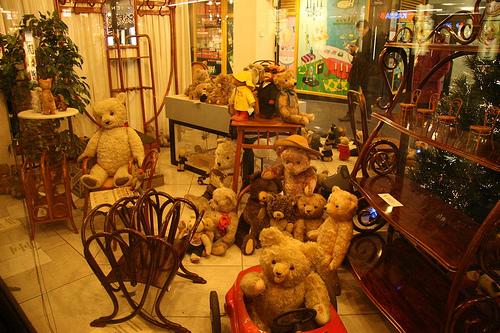What is the bear in the front sitting in?
Give a very brief answer. Car. Is there a teddy bear wearing a raincoat in this scene?
Write a very short answer. Yes. How many teddy bears are wearing clothing items?
Short answer required. 4. 